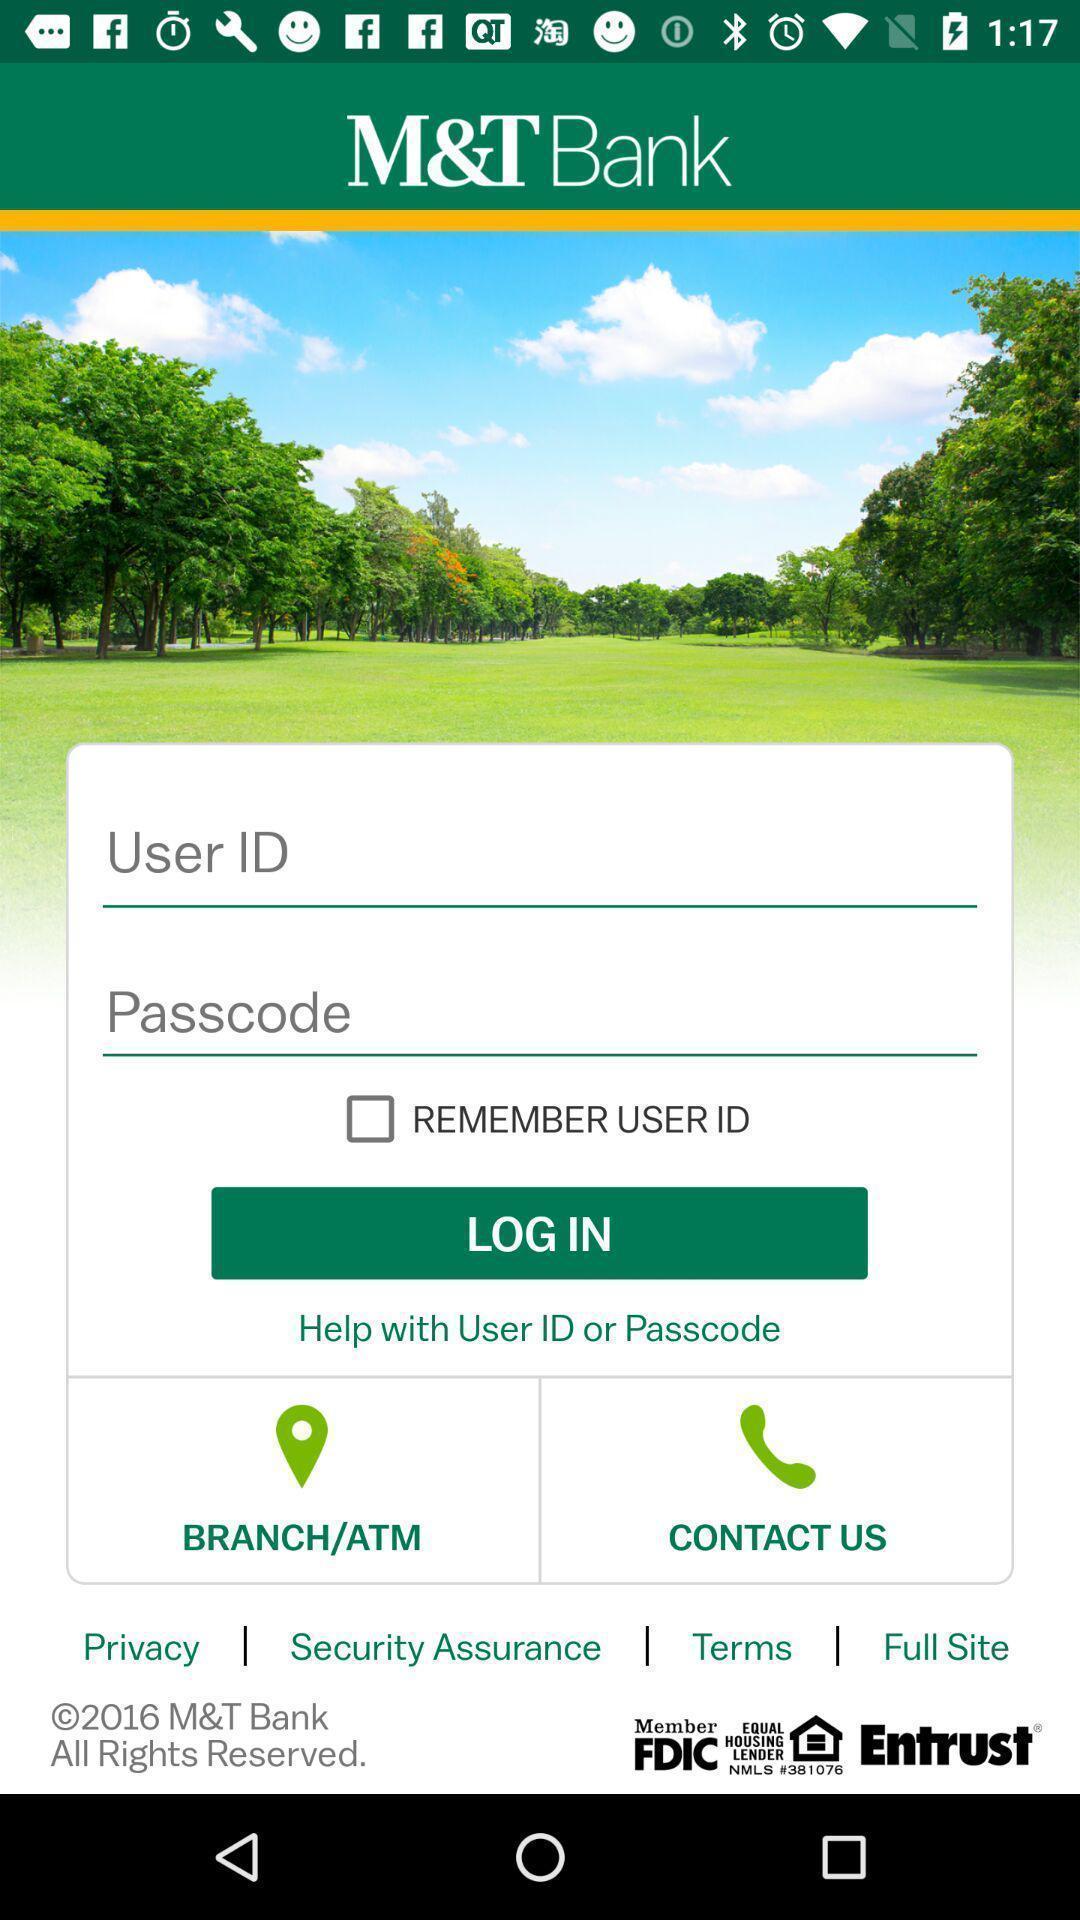Give me a summary of this screen capture. Login page. 